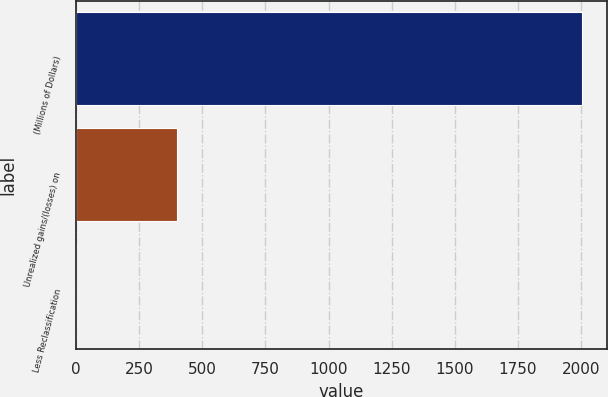Convert chart to OTSL. <chart><loc_0><loc_0><loc_500><loc_500><bar_chart><fcel>(Millions of Dollars)<fcel>Unrealized gains/(losses) on<fcel>Less Reclassification<nl><fcel>2003<fcel>401.4<fcel>1<nl></chart> 